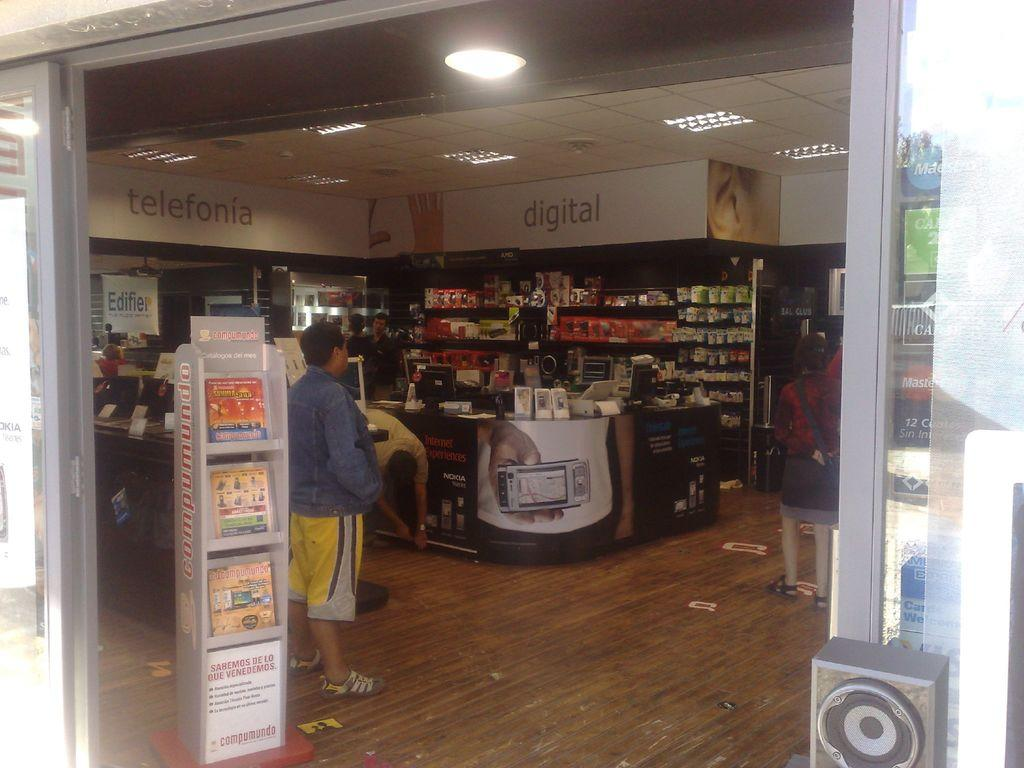Provide a one-sentence caption for the provided image. the inside of a store with displays of Digital and Telefonia. 